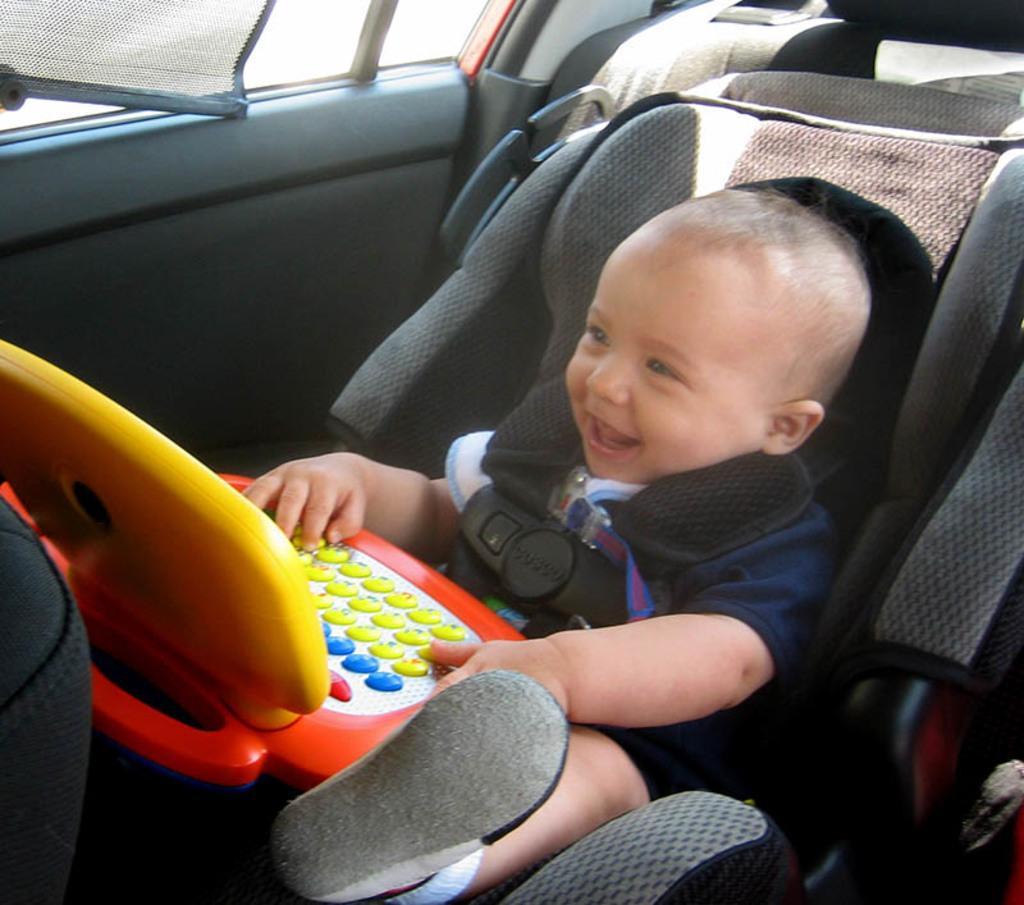Could you give a brief overview of what you see in this image? This image is clicked inside a vehicle. There is an infant sitting on a car seat. There is a belt around him. He is holding an object in his hand. Behind the seat there is a window of the vehicle. 